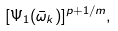<formula> <loc_0><loc_0><loc_500><loc_500>[ \Psi _ { 1 } ( \bar { \omega } _ { k } ) ] ^ { p + 1 / m } ,</formula> 